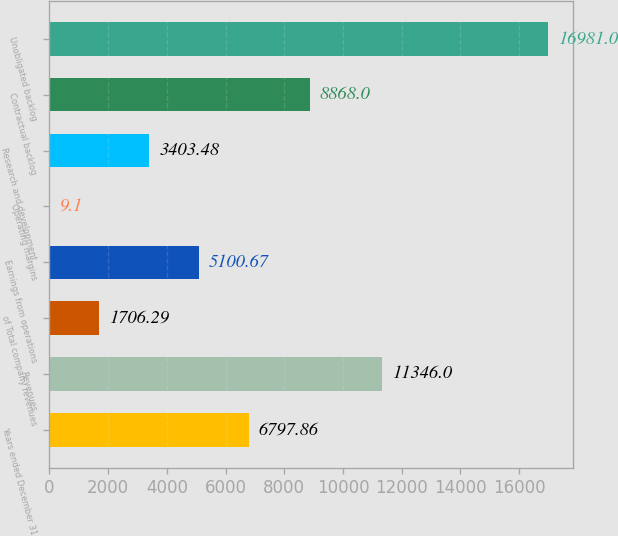Convert chart. <chart><loc_0><loc_0><loc_500><loc_500><bar_chart><fcel>Years ended December 31<fcel>Revenues<fcel>of Total company revenues<fcel>Earnings from operations<fcel>Operating margins<fcel>Research and development<fcel>Contractual backlog<fcel>Unobligated backlog<nl><fcel>6797.86<fcel>11346<fcel>1706.29<fcel>5100.67<fcel>9.1<fcel>3403.48<fcel>8868<fcel>16981<nl></chart> 